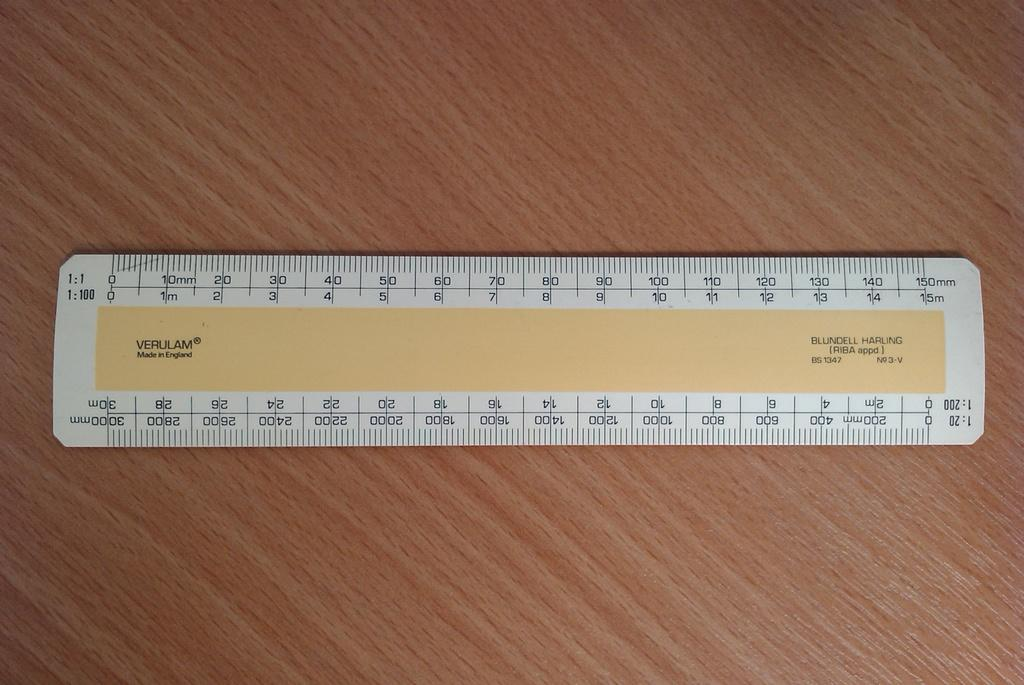<image>
Create a compact narrative representing the image presented. a ruler with the name Verulam on it 